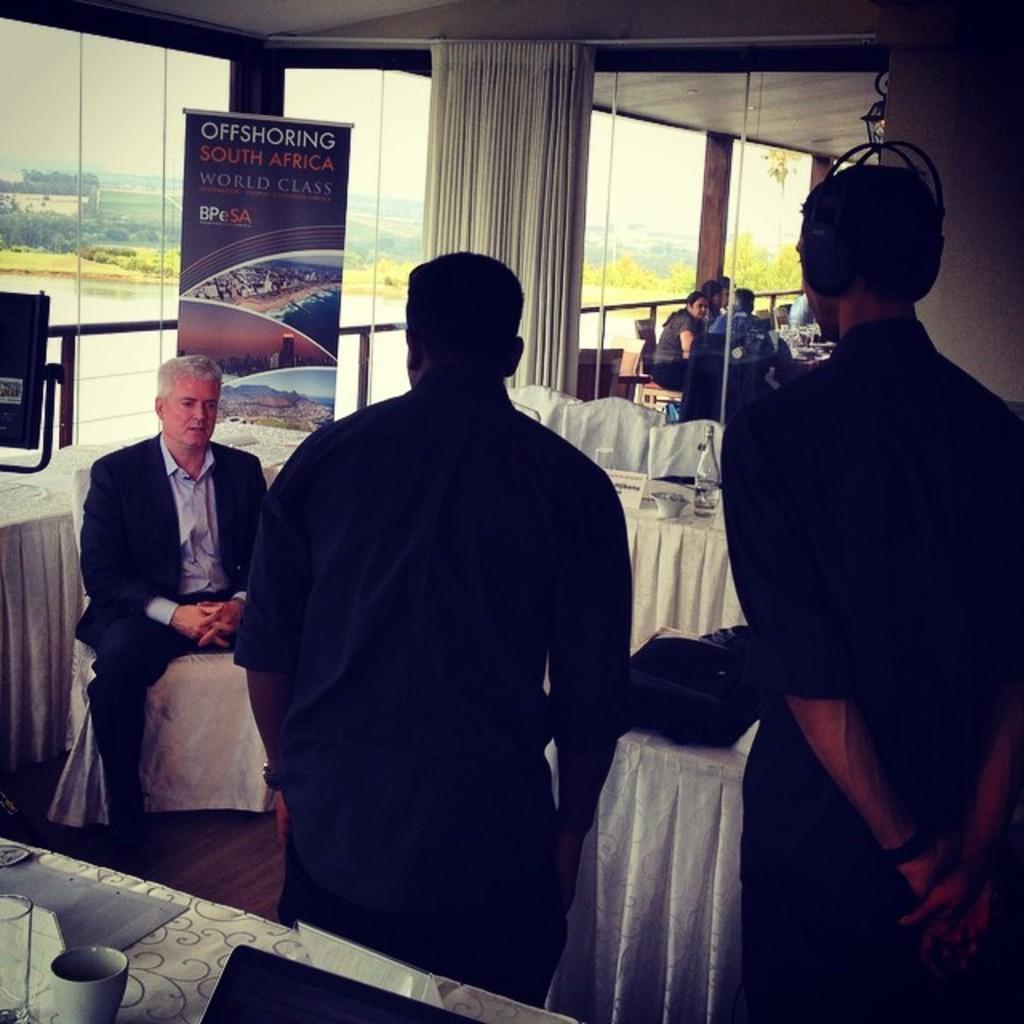Can you describe this image briefly? This image consists of a many people. It looks like a restaurant. In which, we can see the tables and chairs covered with the white clothes. On the left, it looks like windows and doors made up of a glass. In the middle, there is a curtain. At the top, there is a roof. 